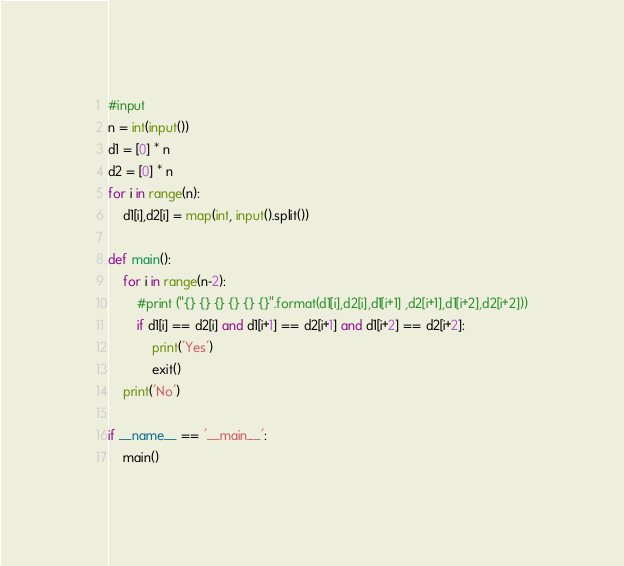<code> <loc_0><loc_0><loc_500><loc_500><_Python_>#input
n = int(input())
d1 = [0] * n
d2 = [0] * n
for i in range(n):
    d1[i],d2[i] = map(int, input().split())

def main():
    for i in range(n-2):
        #print ("{} {} {} {} {} {}".format(d1[i],d2[i],d1[i+1] ,d2[i+1],d1[i+2],d2[i+2]))
        if d1[i] == d2[i] and d1[i+1] == d2[i+1] and d1[i+2] == d2[i+2]:
            print('Yes')
            exit()
    print('No')

if __name__ == '__main__':
    main()</code> 